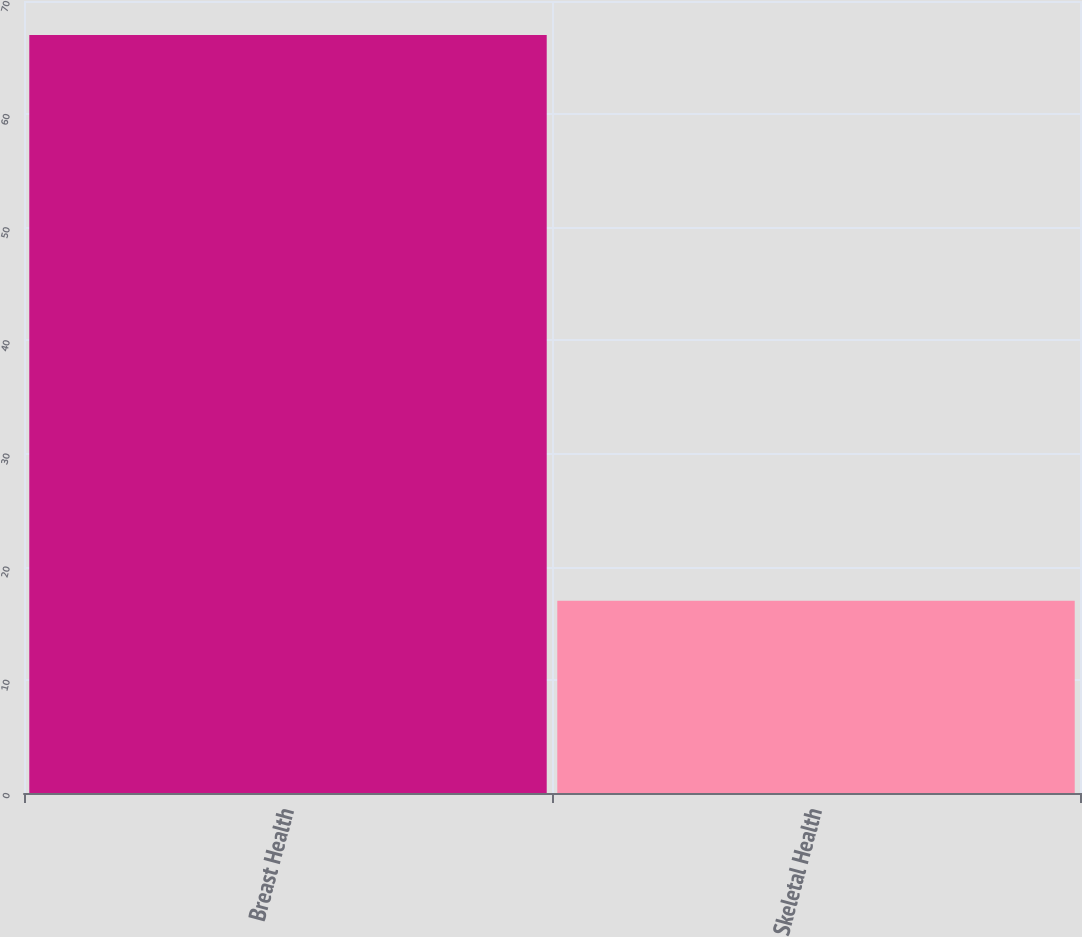<chart> <loc_0><loc_0><loc_500><loc_500><bar_chart><fcel>Breast Health<fcel>Skeletal Health<nl><fcel>67<fcel>17<nl></chart> 